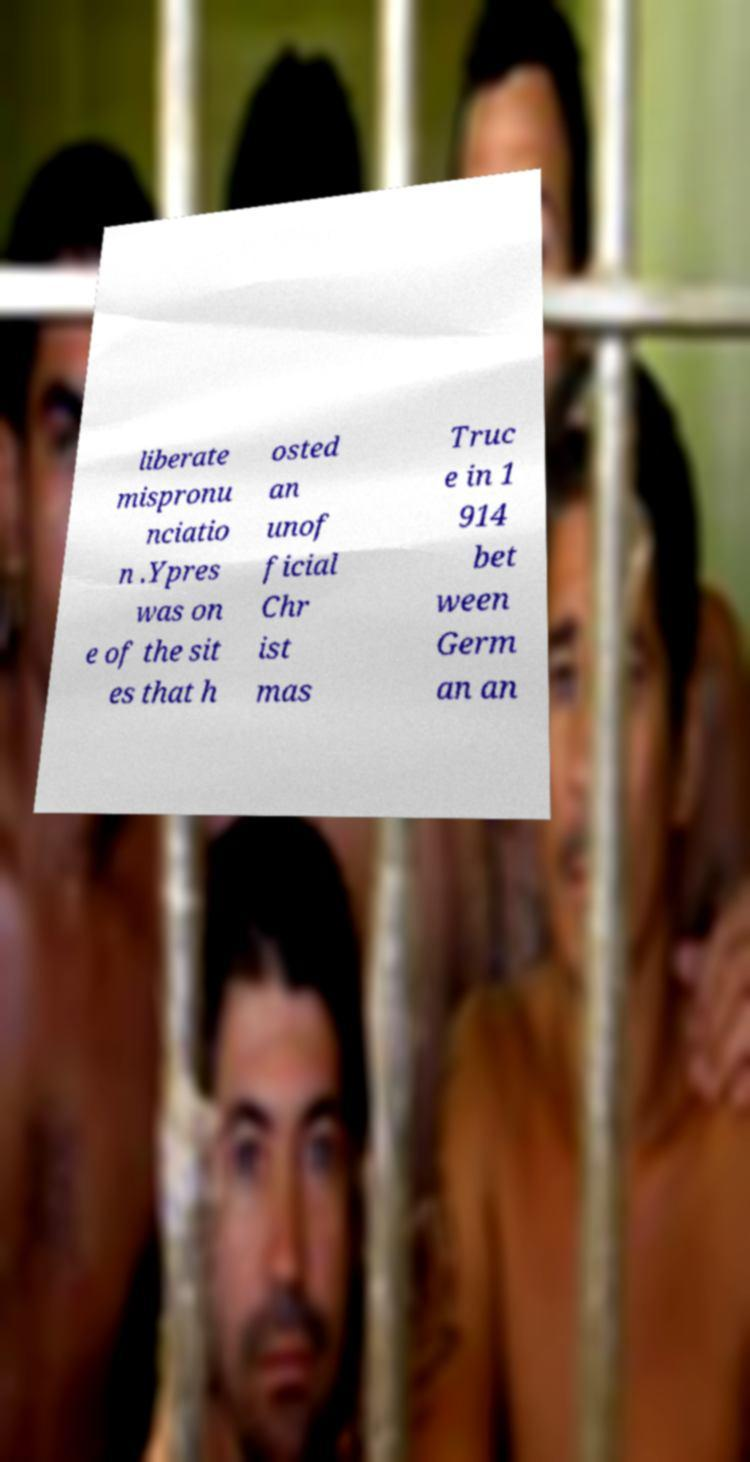Could you extract and type out the text from this image? liberate mispronu nciatio n .Ypres was on e of the sit es that h osted an unof ficial Chr ist mas Truc e in 1 914 bet ween Germ an an 